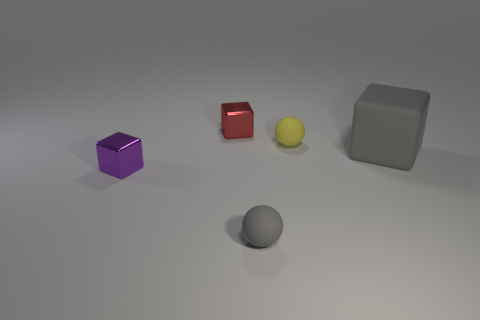Add 5 small rubber cylinders. How many objects exist? 10 Subtract all spheres. How many objects are left? 3 Add 2 cyan matte cylinders. How many cyan matte cylinders exist? 2 Subtract 0 green blocks. How many objects are left? 5 Subtract all purple shiny cubes. Subtract all small matte spheres. How many objects are left? 2 Add 3 tiny things. How many tiny things are left? 7 